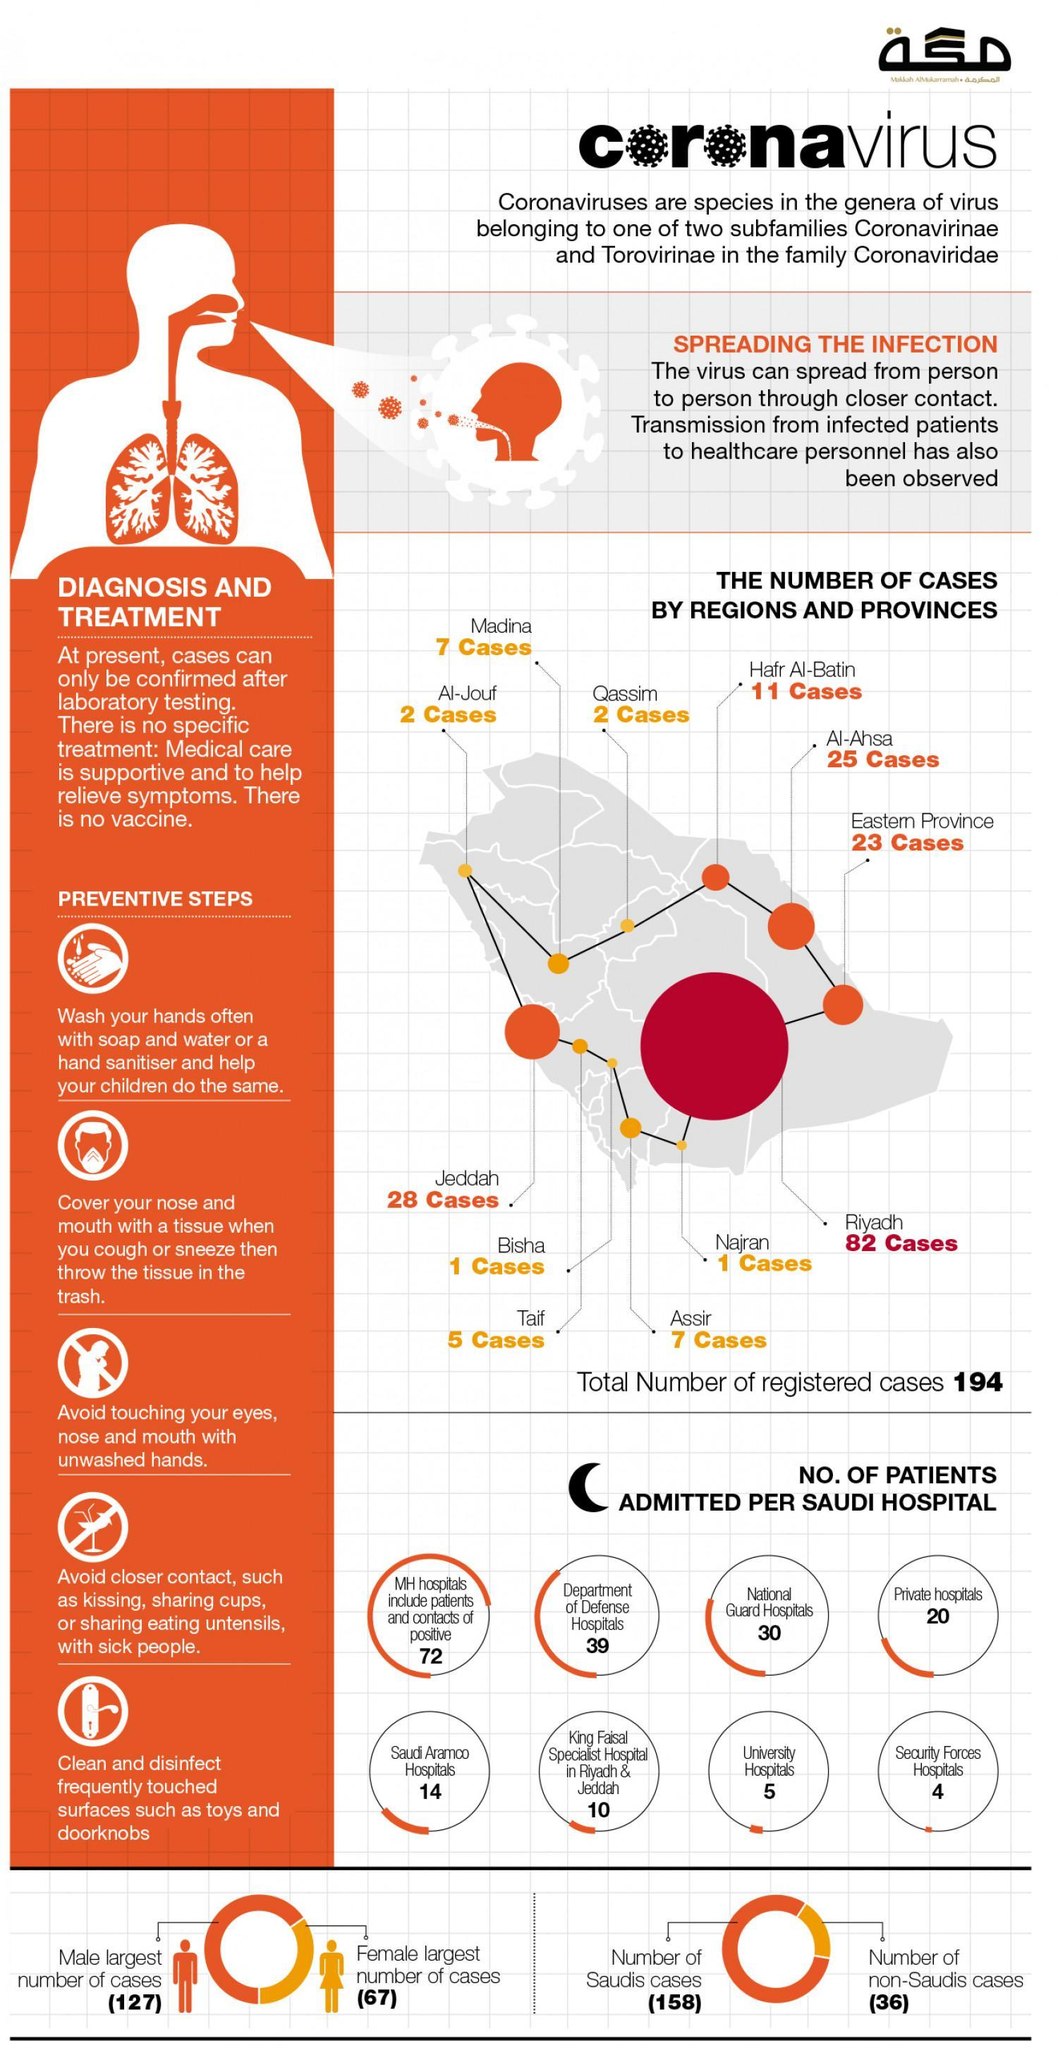How many Covid-19 cases were reported in the eastern province of Saudi Arabia?
Answer the question with a short phrase. 23 How many Covid positive patients are non-Saudi nationals? (36) Which Saudi Arabian City has reported the second highest number of COVID-19 cases? Jeddah How many Covid patients were admitted in the Security Forces hospitals of Saudi Arabia? 4 How many Covid patients were admitted in the private hospitals of Saudi Arabia? 20 Which Saudi Arabian City has reported the highest number of COVID-19 cases? Riyadh How many Covid patients were admitted in the University hospitals of Saudi Arabia? 5 How many Covid positive patients are Saudi nationals? (158) Out of the total number of Covid-19 cases in Saudi Arabia, how many are females? (67) Out of the total number of Covid-19 cases in Saudi Arabia, how many are males? 127 